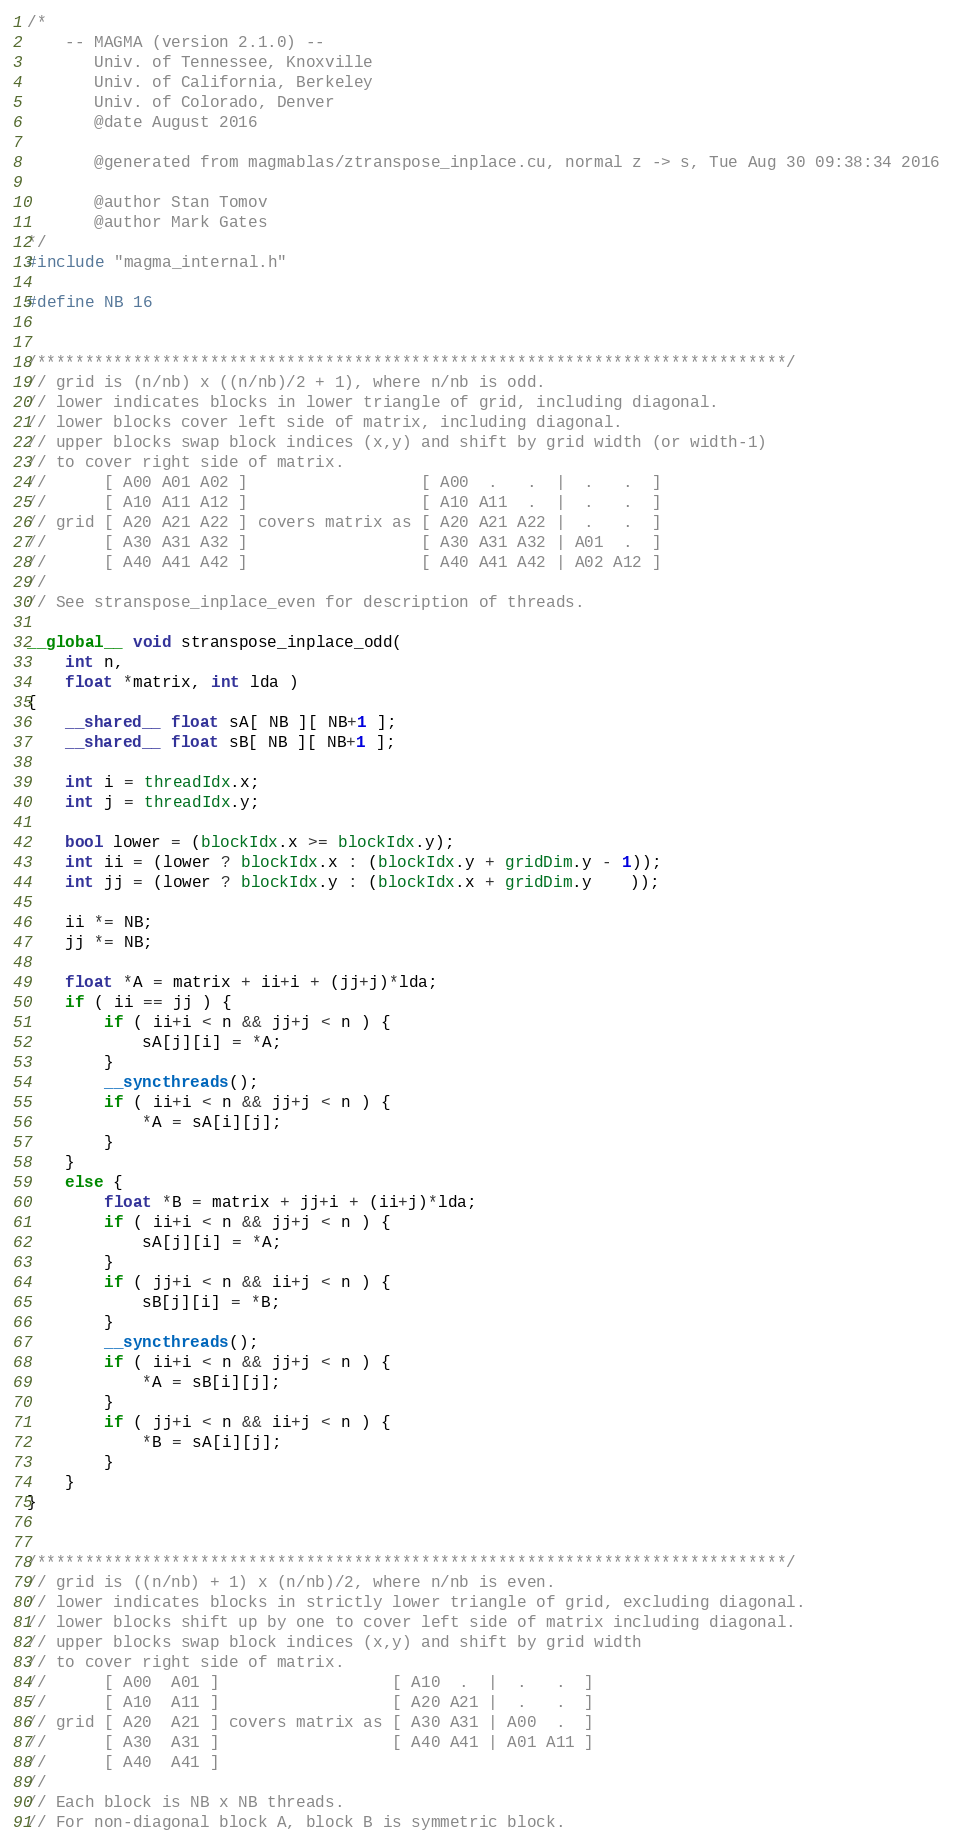<code> <loc_0><loc_0><loc_500><loc_500><_Cuda_>/*
    -- MAGMA (version 2.1.0) --
       Univ. of Tennessee, Knoxville
       Univ. of California, Berkeley
       Univ. of Colorado, Denver
       @date August 2016

       @generated from magmablas/ztranspose_inplace.cu, normal z -> s, Tue Aug 30 09:38:34 2016

       @author Stan Tomov
       @author Mark Gates
*/
#include "magma_internal.h"

#define NB 16


/******************************************************************************/
// grid is (n/nb) x ((n/nb)/2 + 1), where n/nb is odd.
// lower indicates blocks in lower triangle of grid, including diagonal.
// lower blocks cover left side of matrix, including diagonal.
// upper blocks swap block indices (x,y) and shift by grid width (or width-1)
// to cover right side of matrix.
//      [ A00 A01 A02 ]                  [ A00  .   .  |  .   .  ]
//      [ A10 A11 A12 ]                  [ A10 A11  .  |  .   .  ]
// grid [ A20 A21 A22 ] covers matrix as [ A20 A21 A22 |  .   .  ]
//      [ A30 A31 A32 ]                  [ A30 A31 A32 | A01  .  ]
//      [ A40 A41 A42 ]                  [ A40 A41 A42 | A02 A12 ]
// 
// See stranspose_inplace_even for description of threads.

__global__ void stranspose_inplace_odd(
    int n,
    float *matrix, int lda )
{
    __shared__ float sA[ NB ][ NB+1 ];
    __shared__ float sB[ NB ][ NB+1 ];

    int i = threadIdx.x;
    int j = threadIdx.y;

    bool lower = (blockIdx.x >= blockIdx.y);
    int ii = (lower ? blockIdx.x : (blockIdx.y + gridDim.y - 1));
    int jj = (lower ? blockIdx.y : (blockIdx.x + gridDim.y    ));

    ii *= NB;
    jj *= NB;

    float *A = matrix + ii+i + (jj+j)*lda;
    if ( ii == jj ) {
        if ( ii+i < n && jj+j < n ) {
            sA[j][i] = *A;
        }
        __syncthreads();
        if ( ii+i < n && jj+j < n ) {
            *A = sA[i][j];
        }
    }
    else {
        float *B = matrix + jj+i + (ii+j)*lda;
        if ( ii+i < n && jj+j < n ) {
            sA[j][i] = *A;
        }
        if ( jj+i < n && ii+j < n ) {
            sB[j][i] = *B;
        }
        __syncthreads();
        if ( ii+i < n && jj+j < n ) {
            *A = sB[i][j];
        }
        if ( jj+i < n && ii+j < n ) {
            *B = sA[i][j];
        }
    }
}


/******************************************************************************/
// grid is ((n/nb) + 1) x (n/nb)/2, where n/nb is even.
// lower indicates blocks in strictly lower triangle of grid, excluding diagonal.
// lower blocks shift up by one to cover left side of matrix including diagonal.
// upper blocks swap block indices (x,y) and shift by grid width
// to cover right side of matrix.
//      [ A00  A01 ]                  [ A10  .  |  .   .  ]
//      [ A10  A11 ]                  [ A20 A21 |  .   .  ]
// grid [ A20  A21 ] covers matrix as [ A30 A31 | A00  .  ]
//      [ A30  A31 ]                  [ A40 A41 | A01 A11 ]
//      [ A40  A41 ]
//
// Each block is NB x NB threads.
// For non-diagonal block A, block B is symmetric block.</code> 